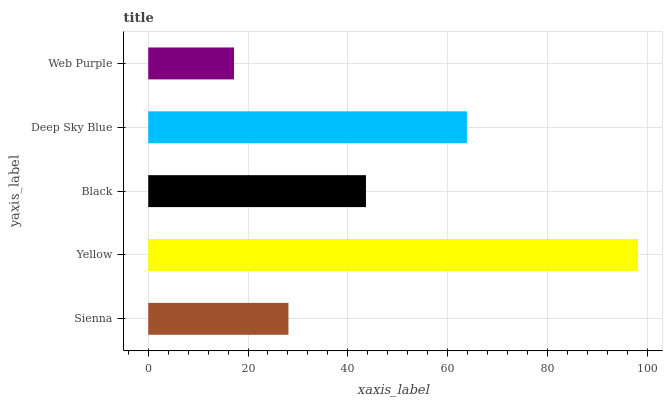Is Web Purple the minimum?
Answer yes or no. Yes. Is Yellow the maximum?
Answer yes or no. Yes. Is Black the minimum?
Answer yes or no. No. Is Black the maximum?
Answer yes or no. No. Is Yellow greater than Black?
Answer yes or no. Yes. Is Black less than Yellow?
Answer yes or no. Yes. Is Black greater than Yellow?
Answer yes or no. No. Is Yellow less than Black?
Answer yes or no. No. Is Black the high median?
Answer yes or no. Yes. Is Black the low median?
Answer yes or no. Yes. Is Yellow the high median?
Answer yes or no. No. Is Yellow the low median?
Answer yes or no. No. 